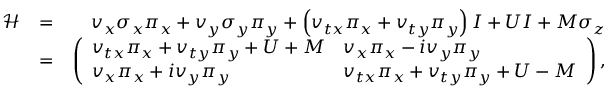<formula> <loc_0><loc_0><loc_500><loc_500>\begin{array} { r l r } { \mathcal { H } } & { = } & { v _ { x } \sigma _ { x } \pi _ { x } + v _ { y } \sigma _ { y } \pi _ { y } + \left ( v _ { t x } \pi _ { x } + v _ { t y } \pi _ { y } \right ) I + U I + M \sigma _ { z } } \\ & { = } & { \left ( \begin{array} { l l } { v _ { t x } \pi _ { x } + v _ { t y } \pi _ { y } + U + M } & { v _ { x } \pi _ { x } - i v _ { y } \pi _ { y } } \\ { v _ { x } \pi _ { x } + i v _ { y } \pi _ { y } } & { v _ { t x } \pi _ { x } + v _ { t y } \pi _ { y } + U - M } \end{array} \right ) , } \end{array}</formula> 